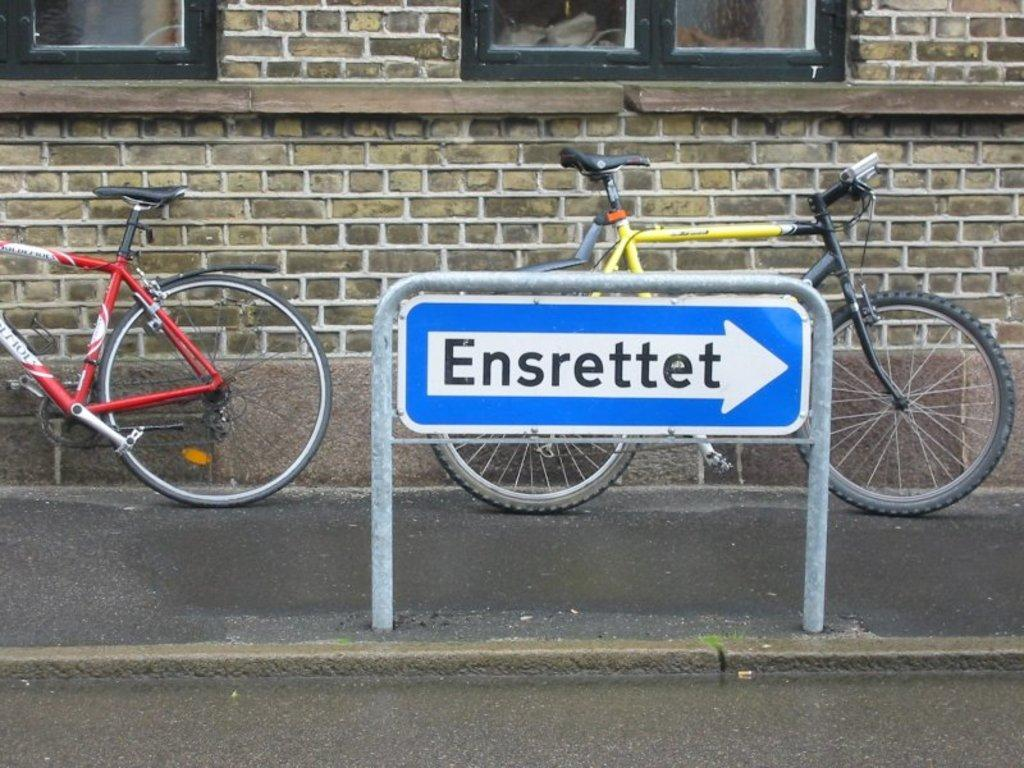How many bicycles are in the image? There are two bicycles in the image. What else can be seen in the image besides the bicycles? There is a board with writing and a building with windows in the image. What type of cake is being crushed by the honey in the image? There is no cake, crush, or honey present in the image. 